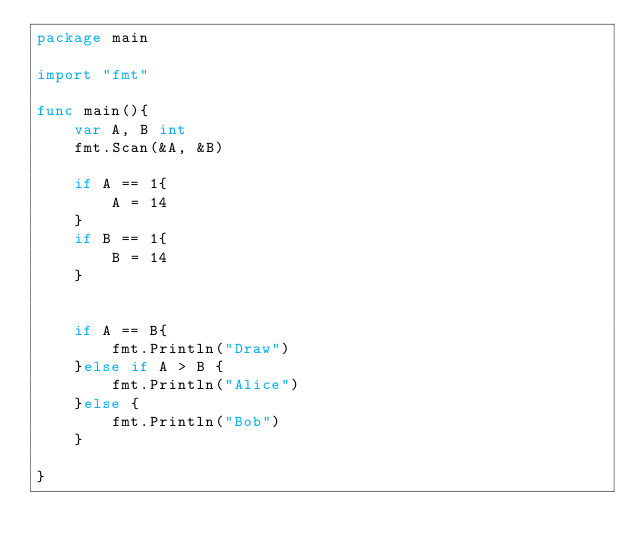Convert code to text. <code><loc_0><loc_0><loc_500><loc_500><_Go_>package main

import "fmt"

func main(){
	var A, B int
	fmt.Scan(&A, &B)

	if A == 1{
		A = 14
	}
	if B == 1{
		B = 14
	}


	if A == B{
		fmt.Println("Draw")
	}else if A > B {
		fmt.Println("Alice")
	}else {
		fmt.Println("Bob")
	}

}</code> 